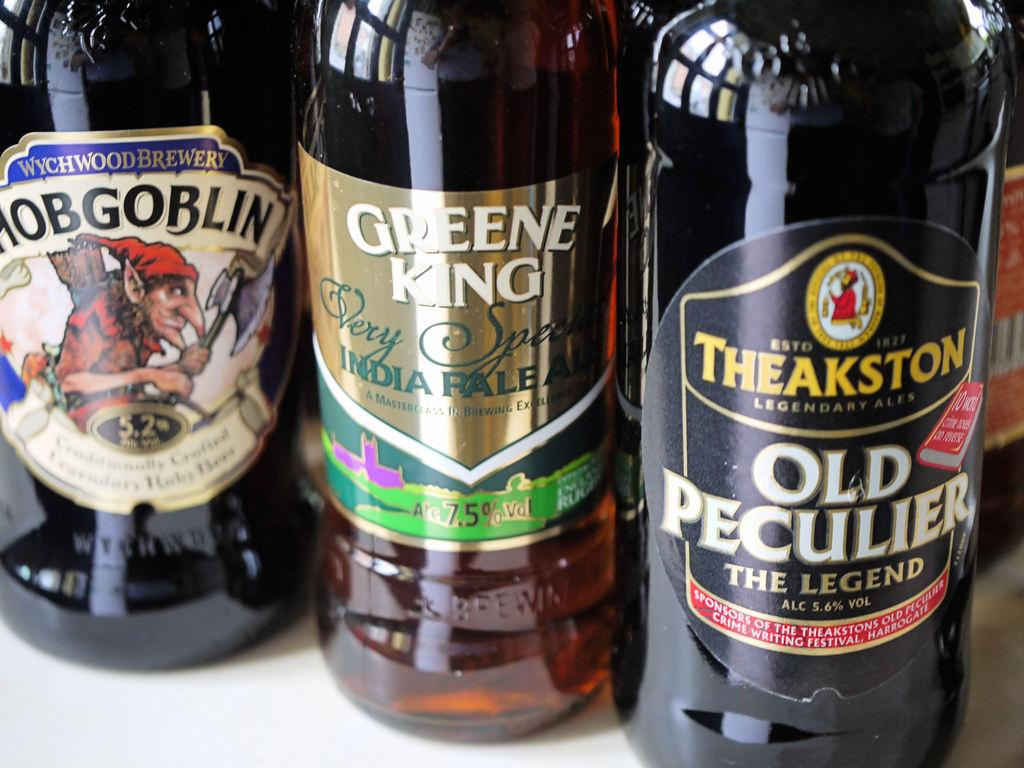Provide a one-sentence caption for the provided image. Three bottles of beer include brands like Hobgoblin and Old Peculier. 